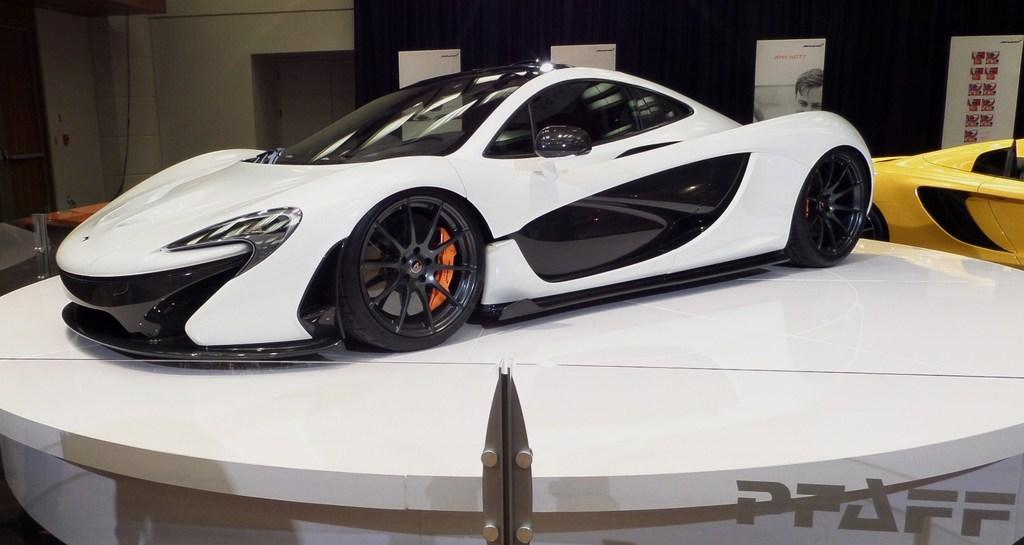What type of toys are on stands in the image? There are toy cars on stands in the image. What can be seen on the board in the background of the image? There are posters on a board in the background of the image. What is visible behind the toy cars and posters? There is a wall visible in the background of the image. How does the steam from the toy cars affect the posters on the board? There is no steam present in the image, as it features toy cars on stands and posters on a board. 